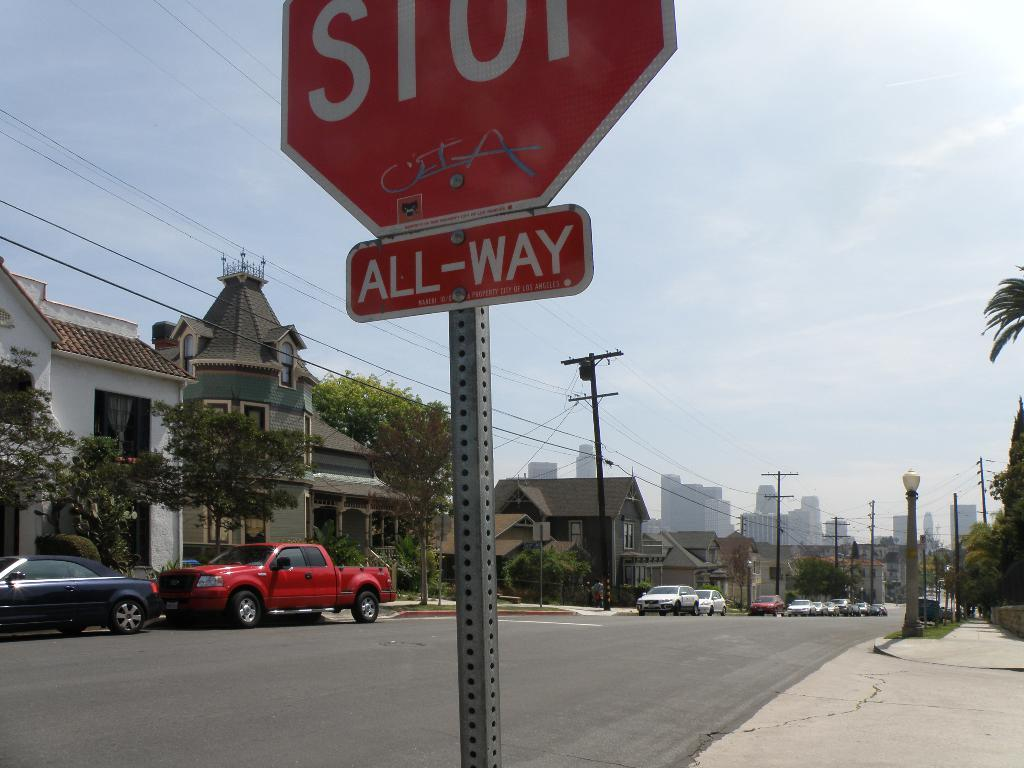<image>
Offer a succinct explanation of the picture presented. The stop sign is there to protect people driving in all directions. 